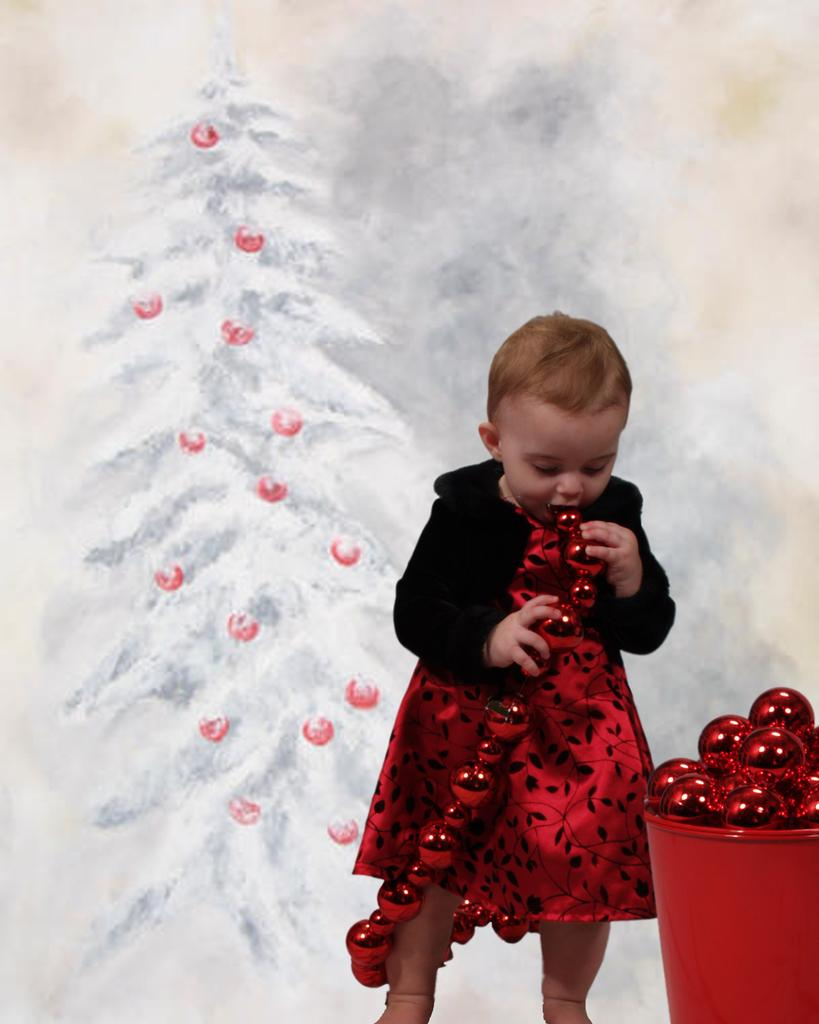Who is the main subject in the image? There is a small girl in the image. What is the girl doing in the image? The girl is playing with objects in the image. Can you describe the bucket in the image? The bucket is red in color and contains objects. What type of stamp can be seen on the girl's forehead in the image? There is no stamp visible on the girl's forehead in the image. 